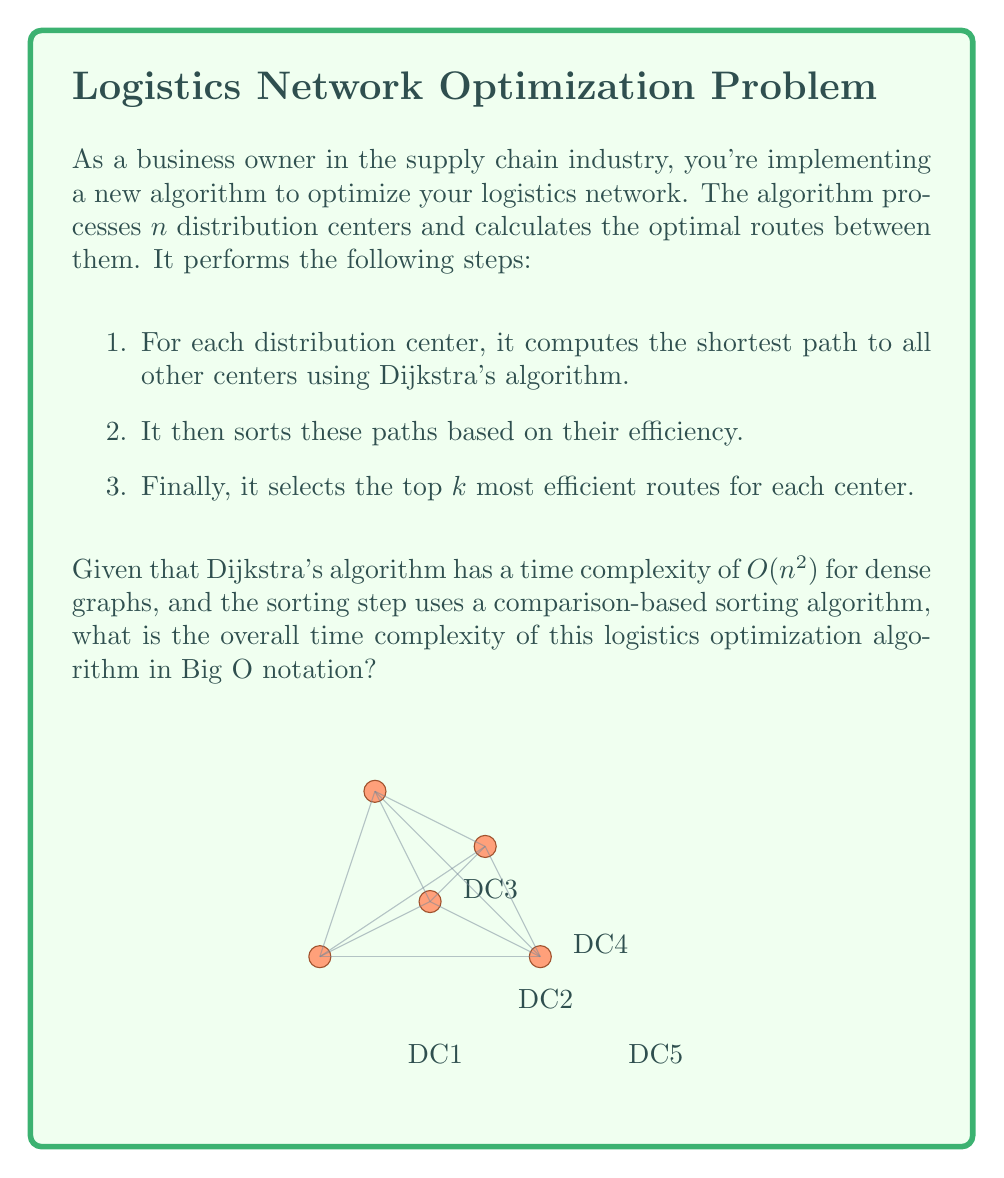Can you solve this math problem? Let's analyze the time complexity step by step:

1. Dijkstra's algorithm:
   - Time complexity for one execution: $O(n^2)$
   - Executed for each of the $n$ distribution centers
   - Total time for this step: $O(n \cdot n^2) = O(n^3)$

2. Sorting step:
   - For each center, we need to sort $n-1$ paths
   - Using a comparison-based sorting algorithm (e.g., Quick Sort or Merge Sort), each sort takes $O(n \log n)$
   - Performed for all $n$ centers
   - Total time for this step: $O(n \cdot n \log n) = O(n^2 \log n)$

3. Selecting top $k$ routes:
   - This can be done in linear time $O(n)$ for each center
   - Total time for this step: $O(n \cdot n) = O(n^2)$

Now, we need to combine these complexities:

$$O(n^3) + O(n^2 \log n) + O(n^2)$$

The dominating term in this sum is $O(n^3)$, as it grows faster than $O(n^2 \log n)$ and $O(n^2)$ for large values of $n$.

Therefore, the overall time complexity of the algorithm is $O(n^3)$.
Answer: $O(n^3)$ 